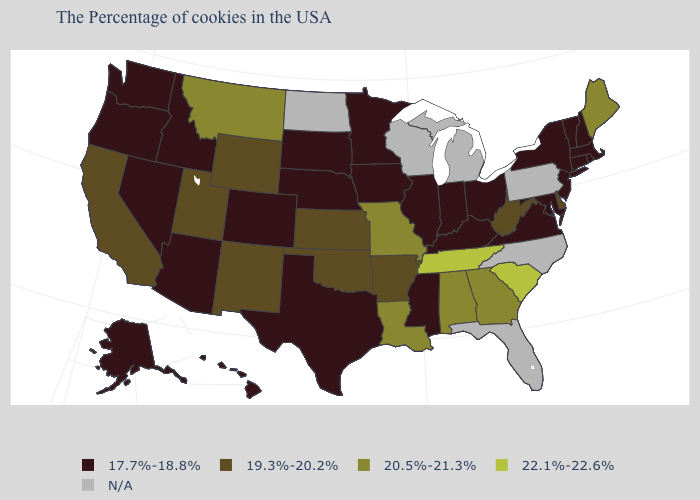What is the value of Rhode Island?
Keep it brief. 17.7%-18.8%. What is the highest value in the USA?
Write a very short answer. 22.1%-22.6%. How many symbols are there in the legend?
Short answer required. 5. Name the states that have a value in the range 20.5%-21.3%?
Write a very short answer. Maine, Georgia, Alabama, Louisiana, Missouri, Montana. What is the value of Nebraska?
Write a very short answer. 17.7%-18.8%. Which states have the highest value in the USA?
Be succinct. South Carolina, Tennessee. Does Louisiana have the lowest value in the South?
Short answer required. No. Name the states that have a value in the range 19.3%-20.2%?
Give a very brief answer. Delaware, West Virginia, Arkansas, Kansas, Oklahoma, Wyoming, New Mexico, Utah, California. Name the states that have a value in the range 20.5%-21.3%?
Answer briefly. Maine, Georgia, Alabama, Louisiana, Missouri, Montana. Which states hav the highest value in the West?
Keep it brief. Montana. Does Maine have the lowest value in the Northeast?
Short answer required. No. How many symbols are there in the legend?
Be succinct. 5. How many symbols are there in the legend?
Be succinct. 5. Which states hav the highest value in the MidWest?
Quick response, please. Missouri. What is the lowest value in states that border Maryland?
Give a very brief answer. 17.7%-18.8%. 